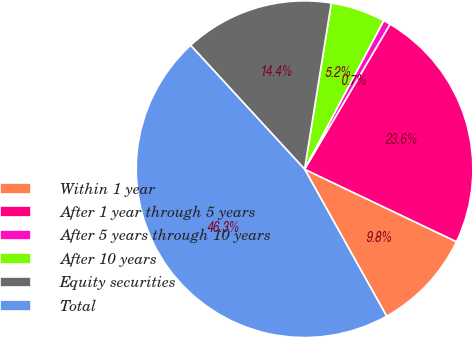<chart> <loc_0><loc_0><loc_500><loc_500><pie_chart><fcel>Within 1 year<fcel>After 1 year through 5 years<fcel>After 5 years through 10 years<fcel>After 10 years<fcel>Equity securities<fcel>Total<nl><fcel>9.81%<fcel>23.61%<fcel>0.69%<fcel>5.25%<fcel>14.37%<fcel>46.27%<nl></chart> 